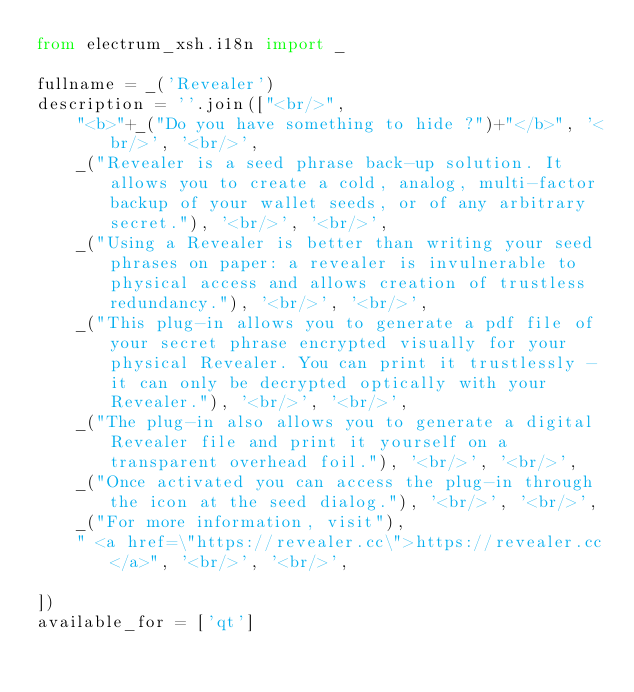<code> <loc_0><loc_0><loc_500><loc_500><_Python_>from electrum_xsh.i18n import _

fullname = _('Revealer')
description = ''.join(["<br/>",
    "<b>"+_("Do you have something to hide ?")+"</b>", '<br/>', '<br/>',
    _("Revealer is a seed phrase back-up solution. It allows you to create a cold, analog, multi-factor backup of your wallet seeds, or of any arbitrary secret."), '<br/>', '<br/>',
    _("Using a Revealer is better than writing your seed phrases on paper: a revealer is invulnerable to physical access and allows creation of trustless redundancy."), '<br/>', '<br/>',
    _("This plug-in allows you to generate a pdf file of your secret phrase encrypted visually for your physical Revealer. You can print it trustlessly - it can only be decrypted optically with your Revealer."), '<br/>', '<br/>',
    _("The plug-in also allows you to generate a digital Revealer file and print it yourself on a transparent overhead foil."), '<br/>', '<br/>',
    _("Once activated you can access the plug-in through the icon at the seed dialog."), '<br/>', '<br/>',
    _("For more information, visit"),
    " <a href=\"https://revealer.cc\">https://revealer.cc</a>", '<br/>', '<br/>',
    
])
available_for = ['qt']


</code> 